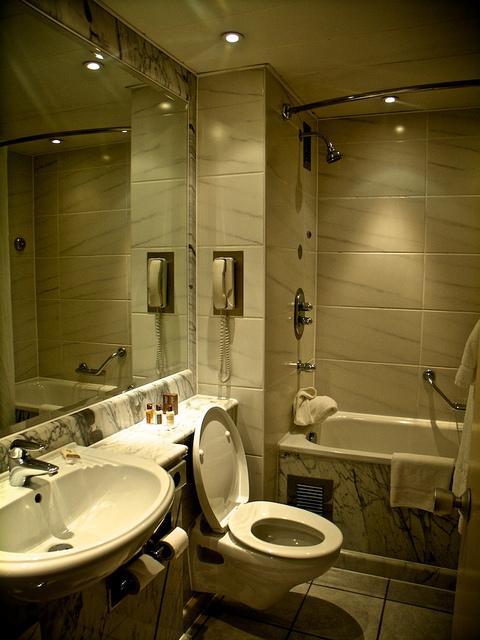What room is this?
Give a very brief answer. Bathroom. Is the bathroom clean?
Quick response, please. Yes. Where is the telephone locate?
Short answer required. Wall. 